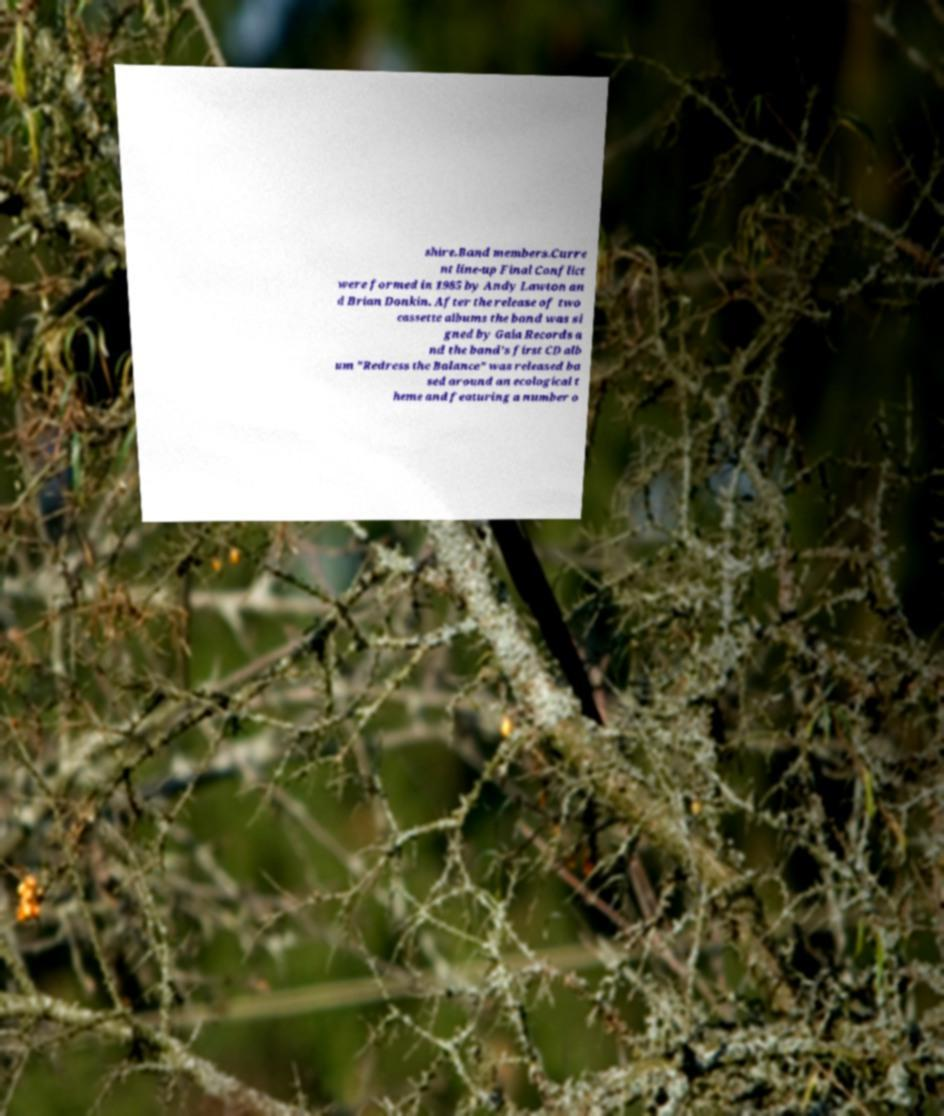Please identify and transcribe the text found in this image. shire.Band members.Curre nt line-up Final Conflict were formed in 1985 by Andy Lawton an d Brian Donkin. After the release of two cassette albums the band was si gned by Gaia Records a nd the band's first CD alb um "Redress the Balance" was released ba sed around an ecological t heme and featuring a number o 